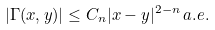<formula> <loc_0><loc_0><loc_500><loc_500>| \Gamma ( x , y ) | \leq C _ { n } | x - y | ^ { 2 - n } \, a . e .</formula> 